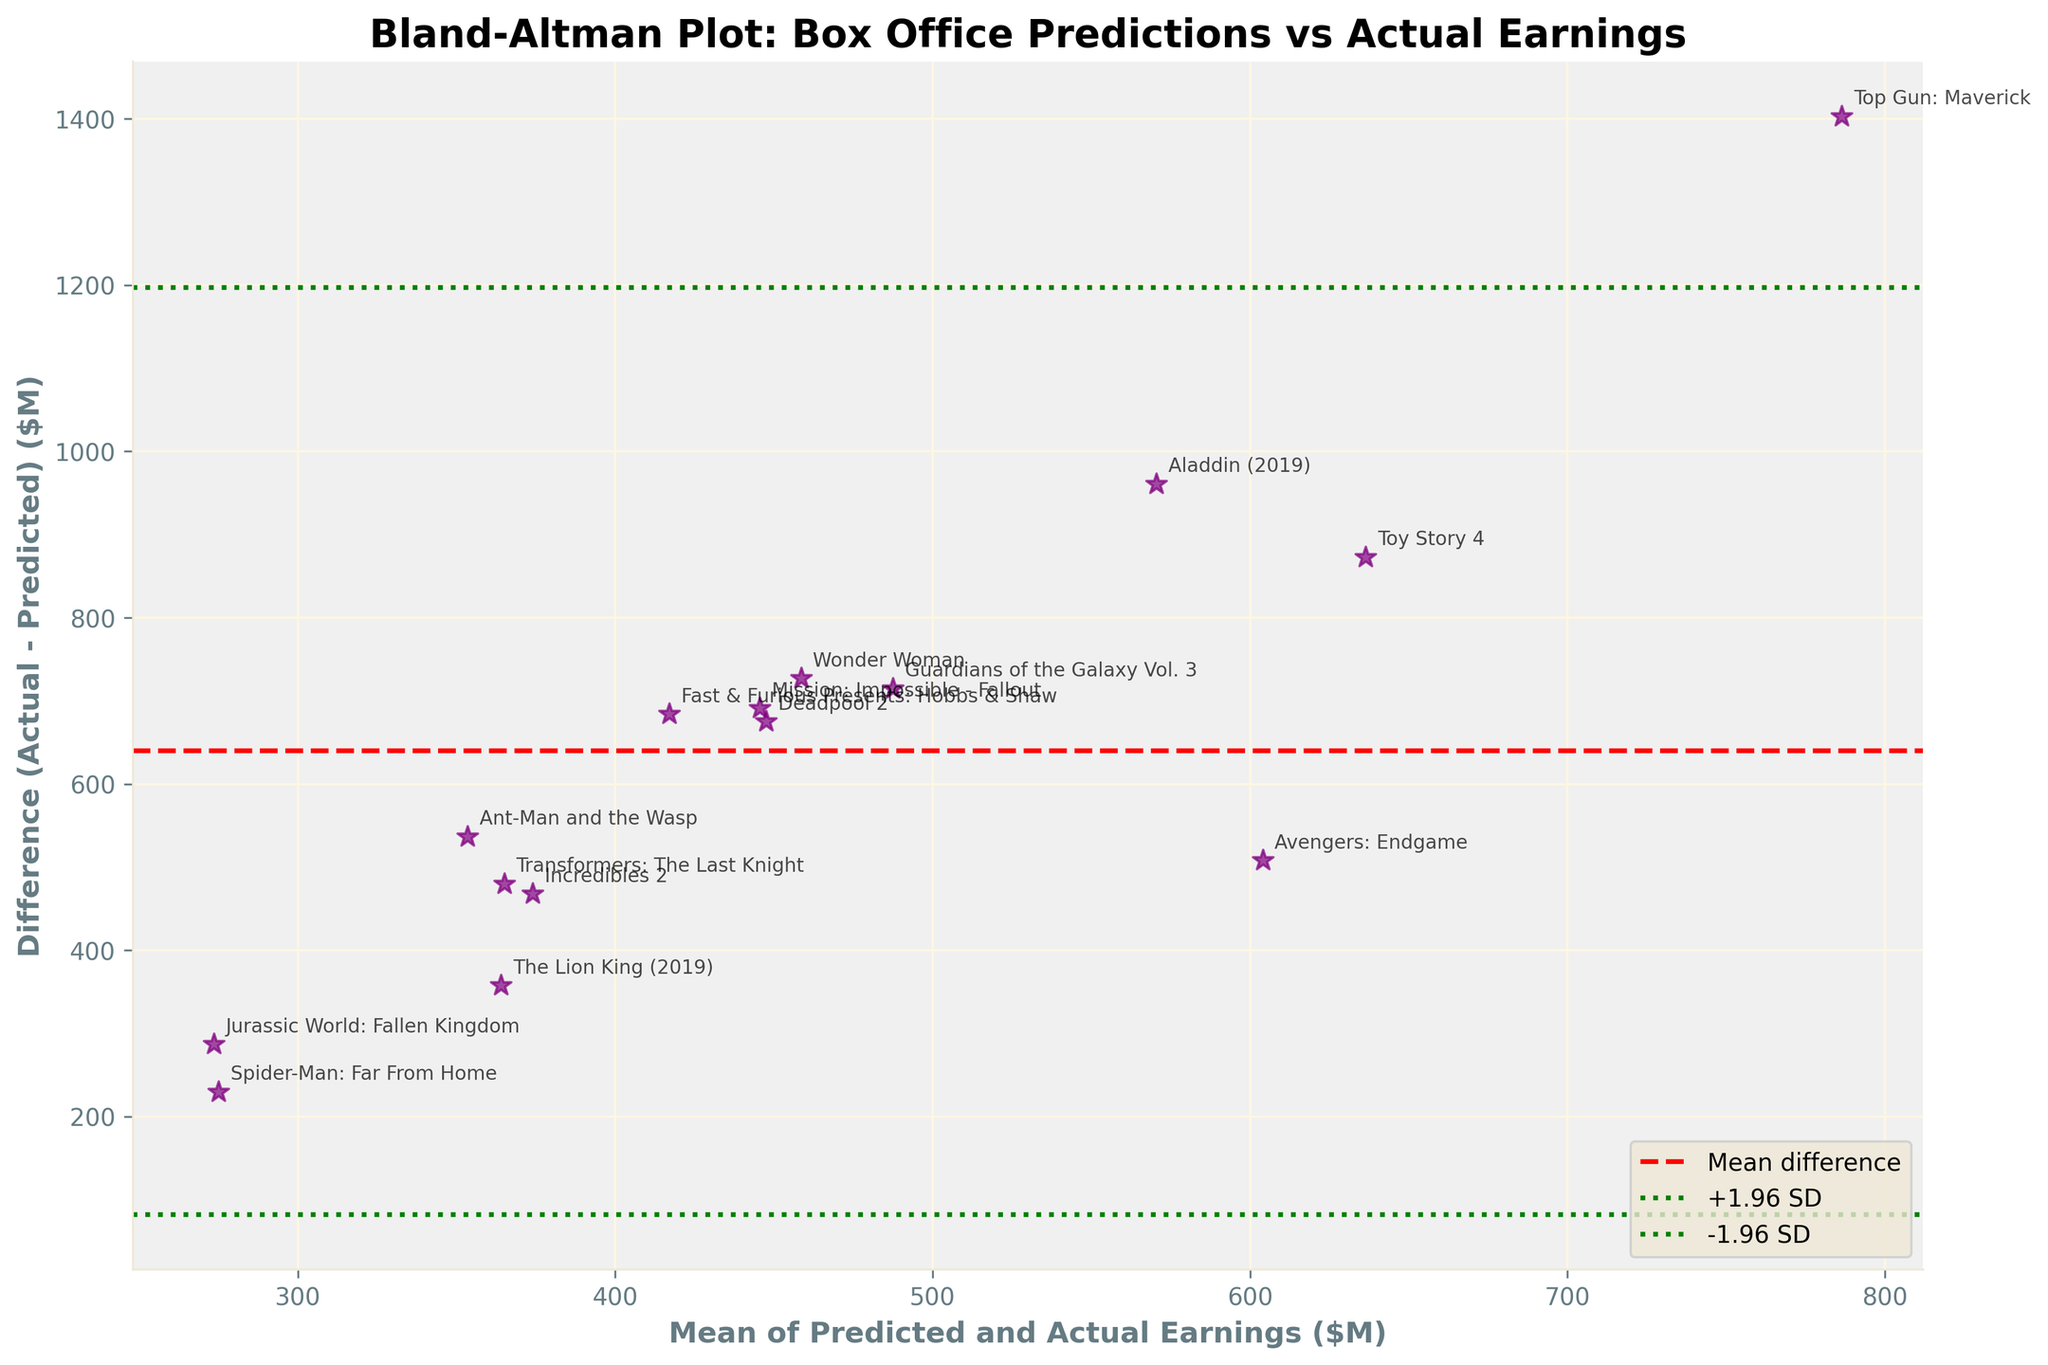How many movies are plotted in the figure? Count the number of data points (stars) on the plot. Each star represents a movie, and counting them reveals there are 15 movies plotted.
Answer: 15 Which movie has the largest positive difference between actual and predicted earnings? Look for the highest point on the y-axis, which represents the largest actual earnings above the predicted value, marked with the movie title. "Top Gun: Maverick" is the highest point.
Answer: Top Gun: Maverick What is the mean difference line value? Identify the horizontal red dashed line labeled "Mean difference" on the plot, which represents the mean difference value.
Answer: Approximately 358.7 million Which movies have actual earnings above their predicted earnings? Identify the stars located above the mean difference line (y-axis > 0) and read their labels.
Answer: Avengers: Endgame, Jurassic World: Fallen Kingdom, The Lion King (2019), Top Gun: Maverick, Spider-Man: Far From Home, Incredibles 2, Guardians of the Galaxy Vol. 3, Mission: Impossible - Fallout, Deadpool 2, Wonder Woman, Fast & Furious Presents: Hobbs & Shaw, Toy Story 4, Aladdin (2019), Transformers: The Last Knight Which movie's actual and predicted earnings have the closest match? Find the star nearest to the horizontal axis (y = 0), indicating the smallest difference between actual and predicted earnings. "Transformers: The Last Knight" is closest to y=0.
Answer: Transformers: The Last Knight How many movies have a difference that lies within ±1.96 standard deviations from the mean difference? Count the stars that fall between the green dotted lines labeled "+1.96 SD" and "-1.96 SD" on the y-axis.
Answer: 12 What is the range of the mean of predicted and actual earnings? Identify the lowest and highest points on the x-axis where data points appear.
Answer: Approximately 70 to 790 million Which movie has the largest discrepancy in its earnings prediction? Identify the largest absolute value on the y-axis, marked with the movie title. "Top Gun: Maverick" is the star with the largest discrepancy.
Answer: Top Gun: Maverick Compare "Toy Story 4" and "Aladdin (2019)" in terms of difference between actual and predicted earnings. Which one has a higher difference? Locate both "Toy Story 4" and "Aladdin (2019)" on the plot and compare their positions on the y-axis. "Toy Story 4" is higher than "Aladdin (2019)".
Answer: Toy Story 4 What are the approximate values of ±1.96 standard deviations from the mean difference visible on the plot? Look at the y-values where the green dotted lines intersect the y-axis.
Answer: Approximately -228.9 million and 946.3 million 